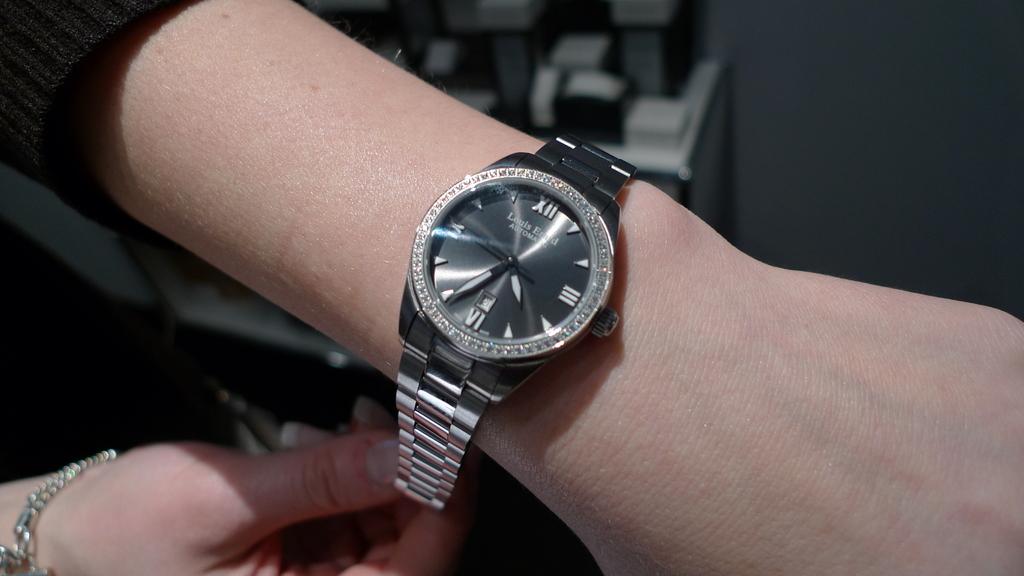What time is on the watch?
Your answer should be very brief. 4:34. What time is it?
Your answer should be very brief. 4:34. 